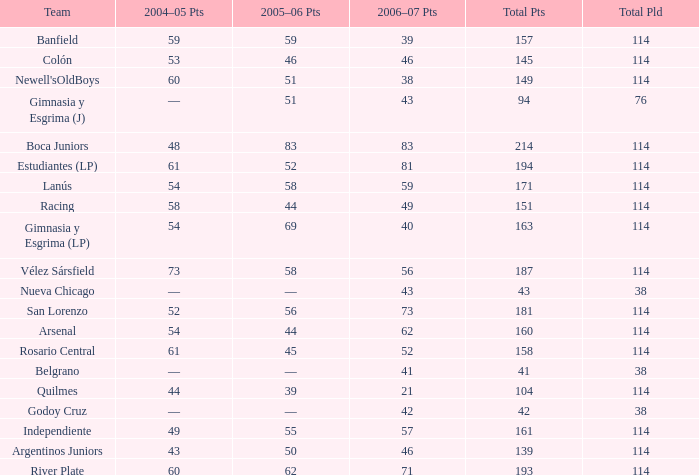What is the average total pld with 45 points in 2005-06, and more than 52 points in 2006-07? None. 